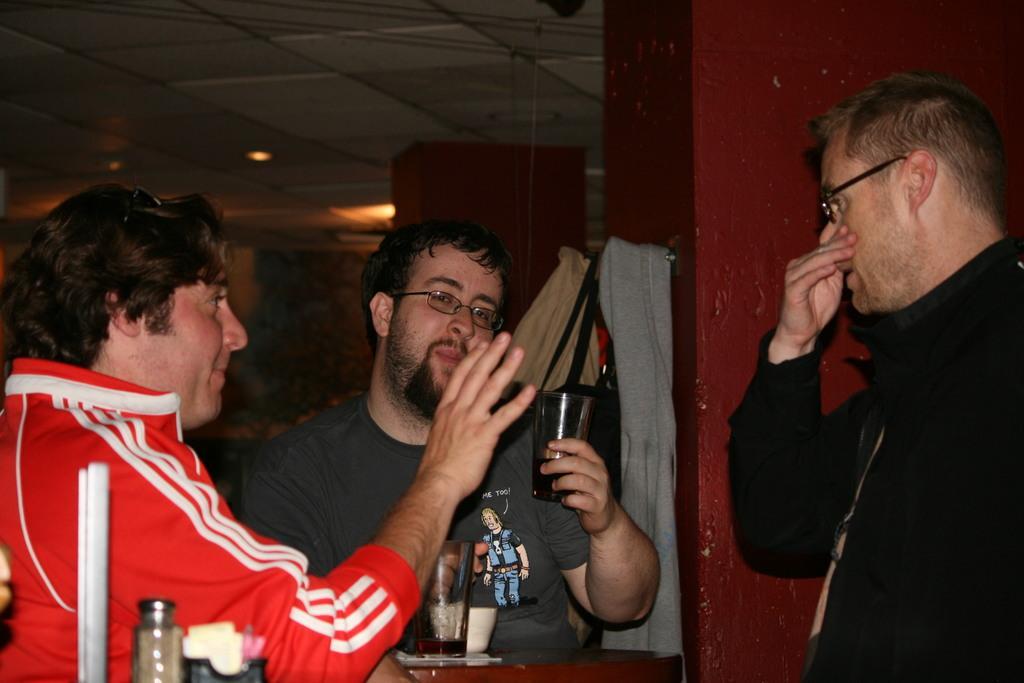Describe this image in one or two sentences. In this image, we can see three people. Two people are wearing glasses. Here a person is holding a glass with liquid. At the bottom, we can see table, few objects. Background we can see pillar, wall, clothes, bag. Top of the image, there is a ceiling with lights. 